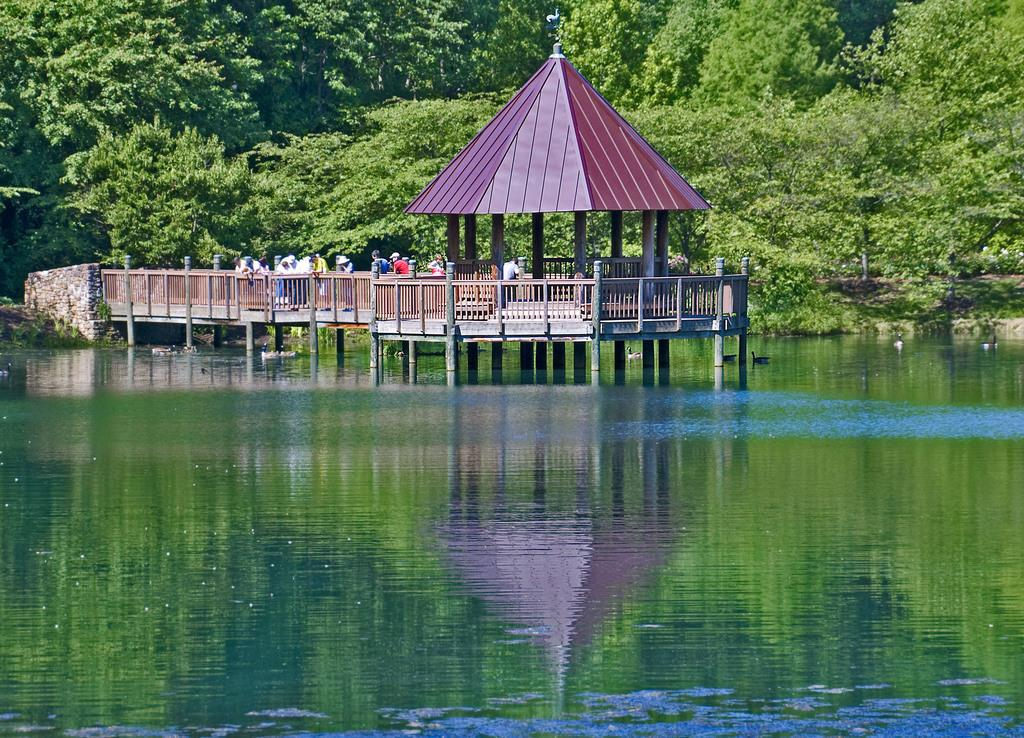What are the people in the image doing? The people in the image are on a path. What type of structure can be seen in the image? There is a hut in the image. What type of vegetation is present in the image? There are trees and plants in the image. What body of water is visible in the image? There is a lake in the image. What type of record is being played in the image? There is no record player or record visible in the image. What color is the roof of the hut in the image? The provided facts do not mention the color of the hut's roof, so we cannot answer this question. 